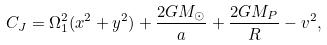<formula> <loc_0><loc_0><loc_500><loc_500>C _ { J } = \Omega _ { 1 } ^ { 2 } ( x ^ { 2 } + y ^ { 2 } ) + \frac { 2 G M _ { \odot } } { a } + \frac { 2 G M _ { P } } { R } - v ^ { 2 } ,</formula> 